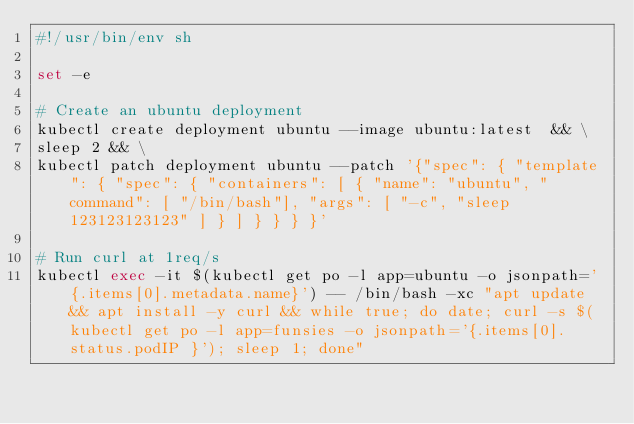Convert code to text. <code><loc_0><loc_0><loc_500><loc_500><_Bash_>#!/usr/bin/env sh

set -e

# Create an ubuntu deployment
kubectl create deployment ubuntu --image ubuntu:latest  && \
sleep 2 && \
kubectl patch deployment ubuntu --patch '{"spec": { "template": { "spec": { "containers": [ { "name": "ubuntu", "command": [ "/bin/bash"], "args": [ "-c", "sleep 123123123123" ] } ] } } } }'

# Run curl at 1req/s
kubectl exec -it $(kubectl get po -l app=ubuntu -o jsonpath='{.items[0].metadata.name}') -- /bin/bash -xc "apt update && apt install -y curl && while true; do date; curl -s $(kubectl get po -l app=funsies -o jsonpath='{.items[0].status.podIP }'); sleep 1; done"
</code> 